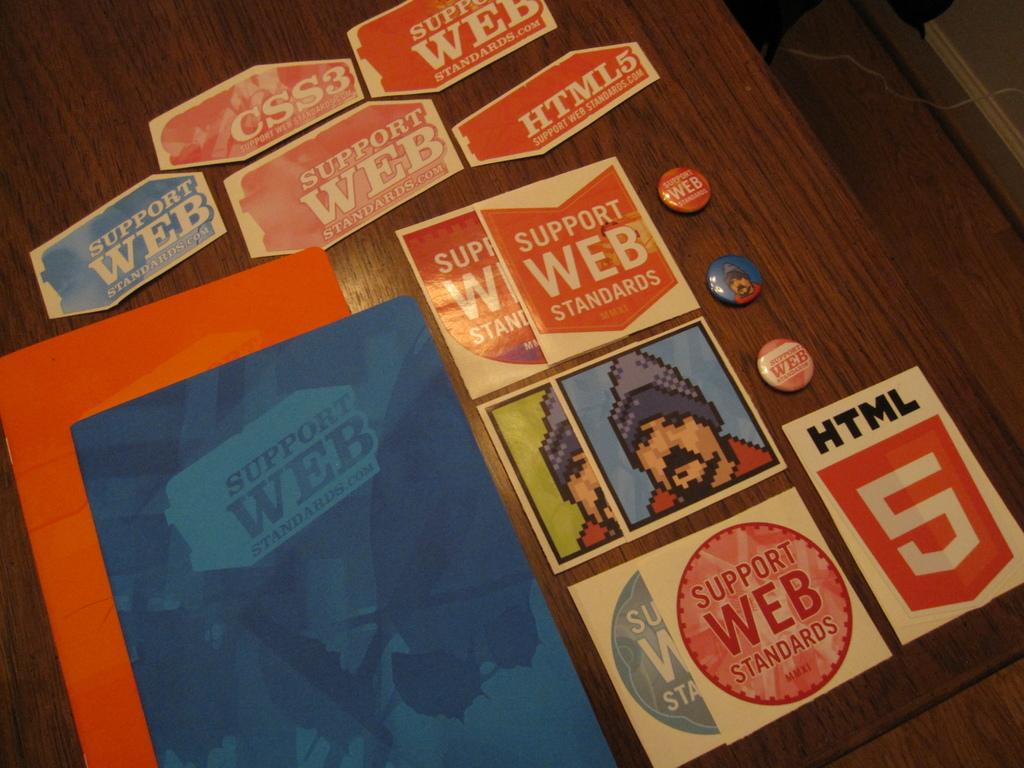What type of items can be seen in the image related to decoration or identification? There are stickers and badges in the image. How many books are visible in the image? There are two books in the image. Where are the books located in the image? The books are kept on a table. What type of caption is written on the books in the image? There is no caption written on the books in the image. What type of punishment is being given to the minister in the image? There is no minister or punishment present in the image. 